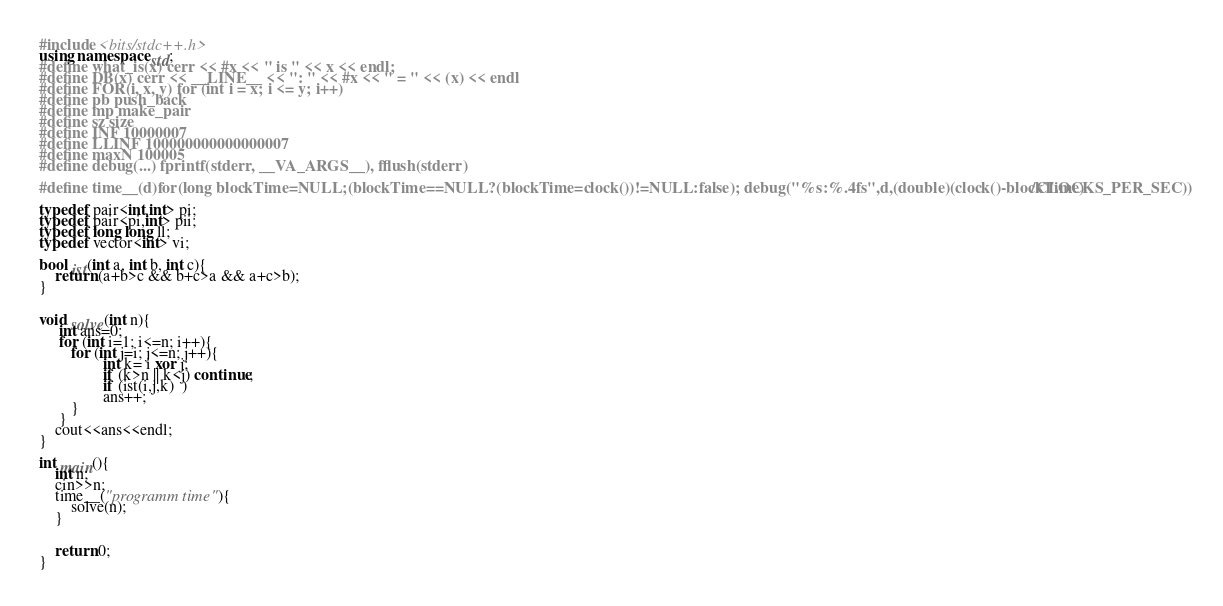Convert code to text. <code><loc_0><loc_0><loc_500><loc_500><_C++_>#include <bits/stdc++.h>
using namespace std;
#define what_is(x) cerr << #x << " is " << x << endl;
#define DB(x) cerr << __LINE__ << ": " << #x << " = " << (x) << endl
#define FOR(i, x, y) for (int i = x; i <= y; i++)
#define pb push_back
#define mp make_pair
#define sz size
#define INF 10000007
#define LLINF 100000000000000007
#define maxN 100005
#define debug(...) fprintf(stderr, __VA_ARGS__), fflush(stderr)
    
#define time__(d)for(long blockTime=NULL;(blockTime==NULL?(blockTime=clock())!=NULL:false); debug("%s:%.4fs",d,(double)(clock()-blockTime)/CLOCKS_PER_SEC))

typedef pair<int,int> pi;
typedef pair<pi,int> pii;
typedef long long ll;
typedef vector<int> vi;

bool ist(int a, int b, int c){
	return (a+b>c && b+c>a && a+c>b);
}


void solve(int n){
	 int ans=0;
     for (int i=1; i<=n; i++){
     	for (int j=i; j<=n; j++){
     	        int k= i xor j;
     			if (k>n || k<j) continue;
     			if (ist(i,j,k)  )
     			ans++;
     	}
     }
    cout<<ans<<endl;
}

int main(){
	int n;
	cin>>n;
	time__("programm time"){
		solve(n);
	}
	
  
	return 0;
}
</code> 